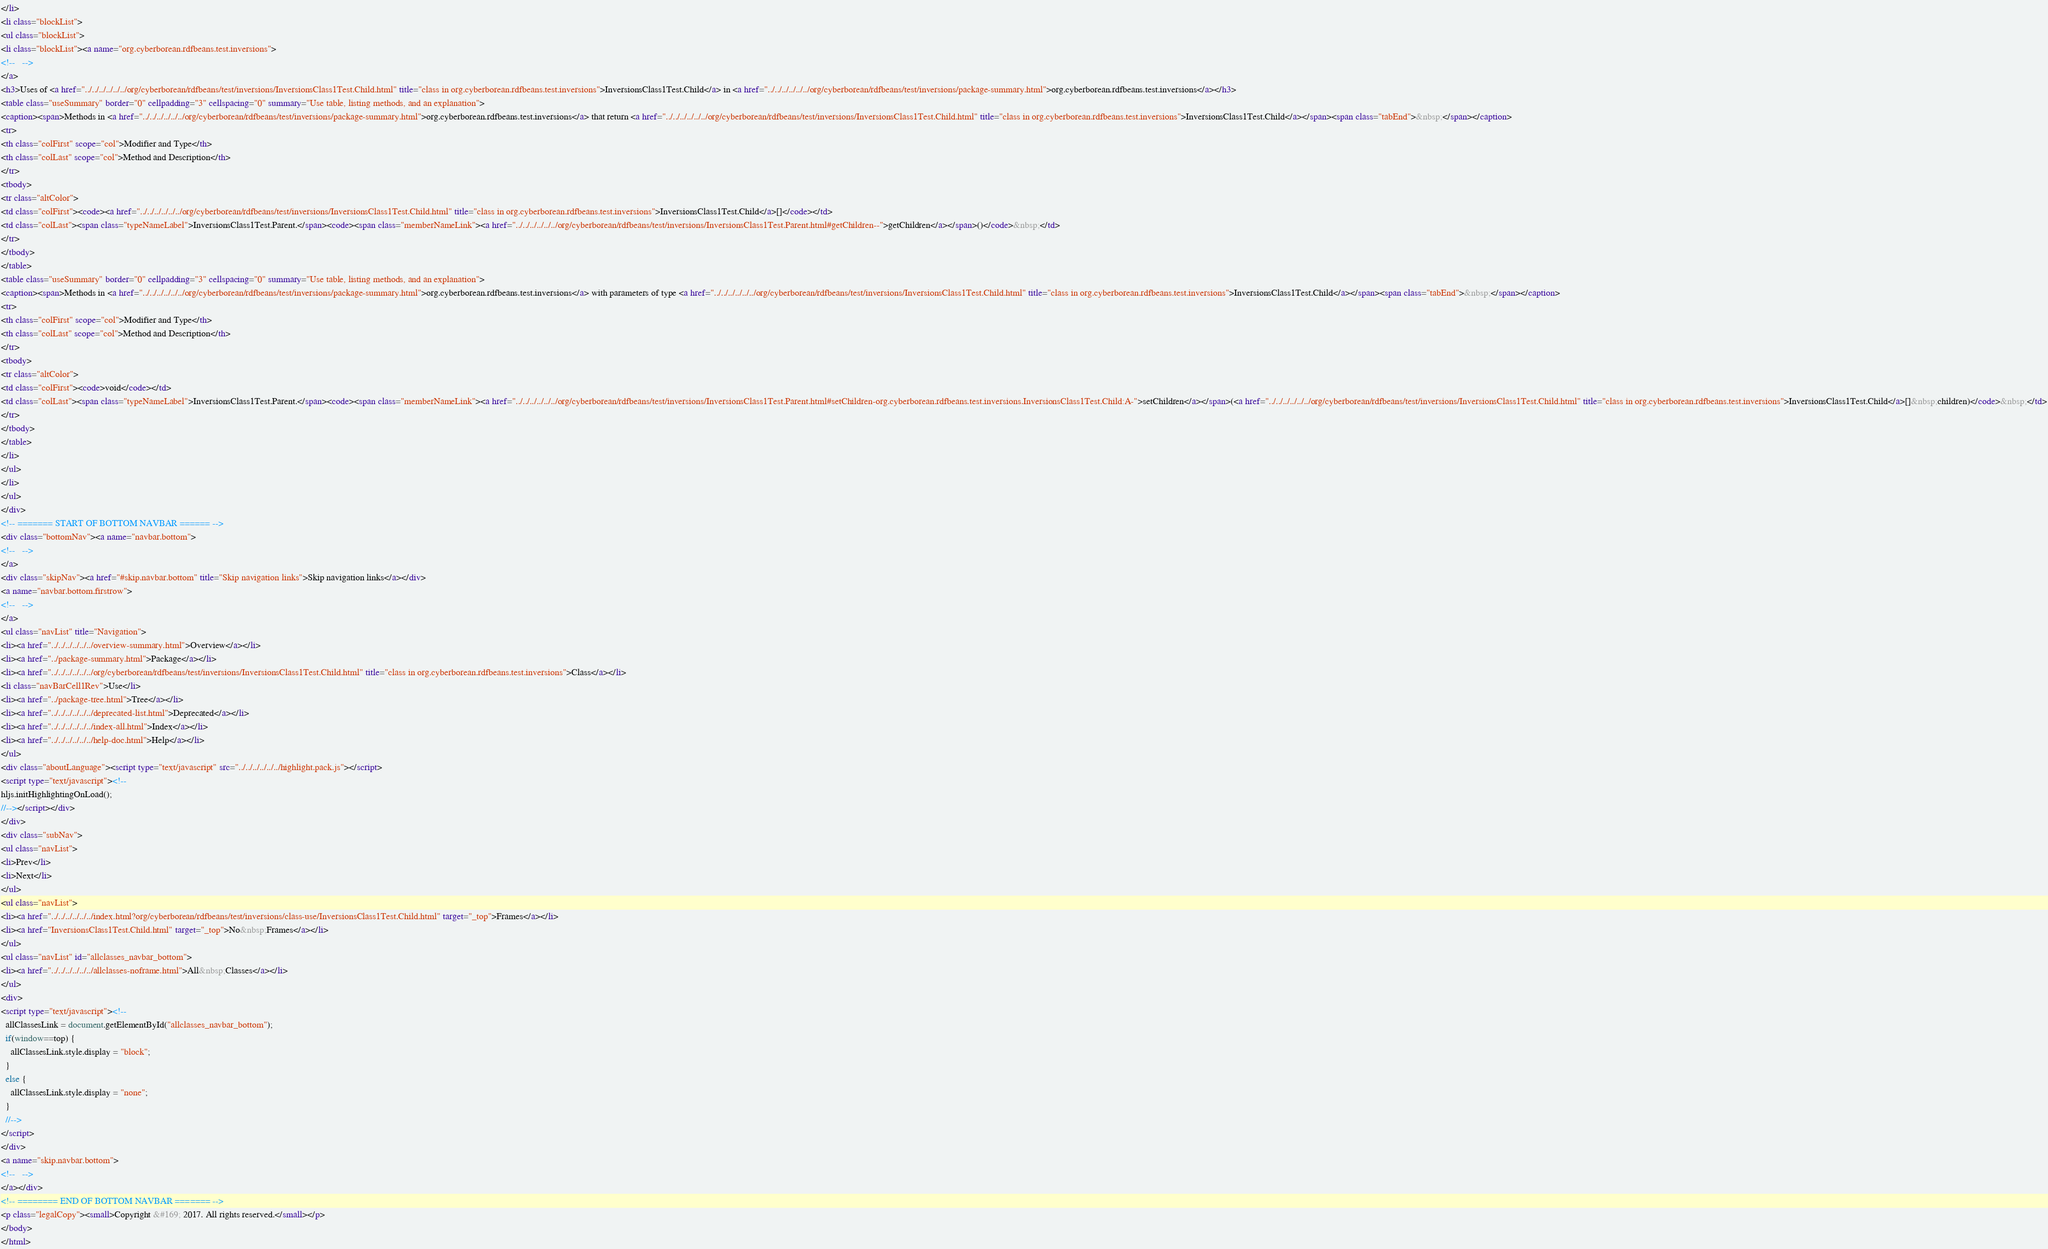Convert code to text. <code><loc_0><loc_0><loc_500><loc_500><_HTML_></li>
<li class="blockList">
<ul class="blockList">
<li class="blockList"><a name="org.cyberborean.rdfbeans.test.inversions">
<!--   -->
</a>
<h3>Uses of <a href="../../../../../../org/cyberborean/rdfbeans/test/inversions/InversionsClass1Test.Child.html" title="class in org.cyberborean.rdfbeans.test.inversions">InversionsClass1Test.Child</a> in <a href="../../../../../../org/cyberborean/rdfbeans/test/inversions/package-summary.html">org.cyberborean.rdfbeans.test.inversions</a></h3>
<table class="useSummary" border="0" cellpadding="3" cellspacing="0" summary="Use table, listing methods, and an explanation">
<caption><span>Methods in <a href="../../../../../../org/cyberborean/rdfbeans/test/inversions/package-summary.html">org.cyberborean.rdfbeans.test.inversions</a> that return <a href="../../../../../../org/cyberborean/rdfbeans/test/inversions/InversionsClass1Test.Child.html" title="class in org.cyberborean.rdfbeans.test.inversions">InversionsClass1Test.Child</a></span><span class="tabEnd">&nbsp;</span></caption>
<tr>
<th class="colFirst" scope="col">Modifier and Type</th>
<th class="colLast" scope="col">Method and Description</th>
</tr>
<tbody>
<tr class="altColor">
<td class="colFirst"><code><a href="../../../../../../org/cyberborean/rdfbeans/test/inversions/InversionsClass1Test.Child.html" title="class in org.cyberborean.rdfbeans.test.inversions">InversionsClass1Test.Child</a>[]</code></td>
<td class="colLast"><span class="typeNameLabel">InversionsClass1Test.Parent.</span><code><span class="memberNameLink"><a href="../../../../../../org/cyberborean/rdfbeans/test/inversions/InversionsClass1Test.Parent.html#getChildren--">getChildren</a></span>()</code>&nbsp;</td>
</tr>
</tbody>
</table>
<table class="useSummary" border="0" cellpadding="3" cellspacing="0" summary="Use table, listing methods, and an explanation">
<caption><span>Methods in <a href="../../../../../../org/cyberborean/rdfbeans/test/inversions/package-summary.html">org.cyberborean.rdfbeans.test.inversions</a> with parameters of type <a href="../../../../../../org/cyberborean/rdfbeans/test/inversions/InversionsClass1Test.Child.html" title="class in org.cyberborean.rdfbeans.test.inversions">InversionsClass1Test.Child</a></span><span class="tabEnd">&nbsp;</span></caption>
<tr>
<th class="colFirst" scope="col">Modifier and Type</th>
<th class="colLast" scope="col">Method and Description</th>
</tr>
<tbody>
<tr class="altColor">
<td class="colFirst"><code>void</code></td>
<td class="colLast"><span class="typeNameLabel">InversionsClass1Test.Parent.</span><code><span class="memberNameLink"><a href="../../../../../../org/cyberborean/rdfbeans/test/inversions/InversionsClass1Test.Parent.html#setChildren-org.cyberborean.rdfbeans.test.inversions.InversionsClass1Test.Child:A-">setChildren</a></span>(<a href="../../../../../../org/cyberborean/rdfbeans/test/inversions/InversionsClass1Test.Child.html" title="class in org.cyberborean.rdfbeans.test.inversions">InversionsClass1Test.Child</a>[]&nbsp;children)</code>&nbsp;</td>
</tr>
</tbody>
</table>
</li>
</ul>
</li>
</ul>
</div>
<!-- ======= START OF BOTTOM NAVBAR ====== -->
<div class="bottomNav"><a name="navbar.bottom">
<!--   -->
</a>
<div class="skipNav"><a href="#skip.navbar.bottom" title="Skip navigation links">Skip navigation links</a></div>
<a name="navbar.bottom.firstrow">
<!--   -->
</a>
<ul class="navList" title="Navigation">
<li><a href="../../../../../../overview-summary.html">Overview</a></li>
<li><a href="../package-summary.html">Package</a></li>
<li><a href="../../../../../../org/cyberborean/rdfbeans/test/inversions/InversionsClass1Test.Child.html" title="class in org.cyberborean.rdfbeans.test.inversions">Class</a></li>
<li class="navBarCell1Rev">Use</li>
<li><a href="../package-tree.html">Tree</a></li>
<li><a href="../../../../../../deprecated-list.html">Deprecated</a></li>
<li><a href="../../../../../../index-all.html">Index</a></li>
<li><a href="../../../../../../help-doc.html">Help</a></li>
</ul>
<div class="aboutLanguage"><script type="text/javascript" src="../../../../../../highlight.pack.js"></script>
<script type="text/javascript"><!--
hljs.initHighlightingOnLoad();
//--></script></div>
</div>
<div class="subNav">
<ul class="navList">
<li>Prev</li>
<li>Next</li>
</ul>
<ul class="navList">
<li><a href="../../../../../../index.html?org/cyberborean/rdfbeans/test/inversions/class-use/InversionsClass1Test.Child.html" target="_top">Frames</a></li>
<li><a href="InversionsClass1Test.Child.html" target="_top">No&nbsp;Frames</a></li>
</ul>
<ul class="navList" id="allclasses_navbar_bottom">
<li><a href="../../../../../../allclasses-noframe.html">All&nbsp;Classes</a></li>
</ul>
<div>
<script type="text/javascript"><!--
  allClassesLink = document.getElementById("allclasses_navbar_bottom");
  if(window==top) {
    allClassesLink.style.display = "block";
  }
  else {
    allClassesLink.style.display = "none";
  }
  //-->
</script>
</div>
<a name="skip.navbar.bottom">
<!--   -->
</a></div>
<!-- ======== END OF BOTTOM NAVBAR ======= -->
<p class="legalCopy"><small>Copyright &#169; 2017. All rights reserved.</small></p>
</body>
</html>
</code> 